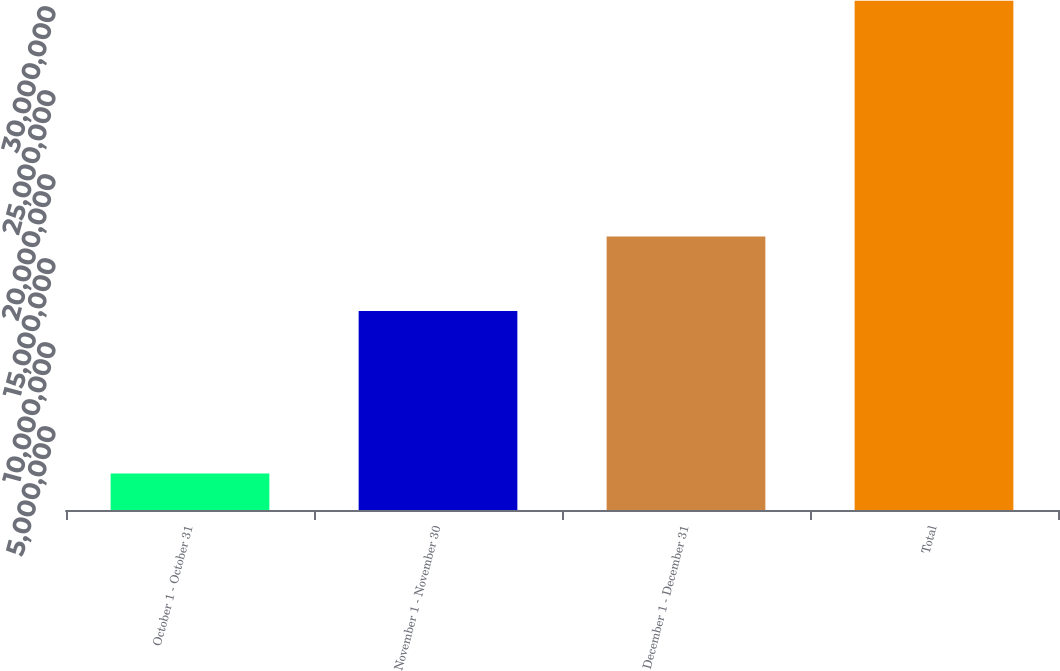Convert chart to OTSL. <chart><loc_0><loc_0><loc_500><loc_500><bar_chart><fcel>October 1 - October 31<fcel>November 1 - November 30<fcel>December 1 - December 31<fcel>Total<nl><fcel>2.17234e+06<fcel>1.18503e+07<fcel>1.6285e+07<fcel>3.03077e+07<nl></chart> 